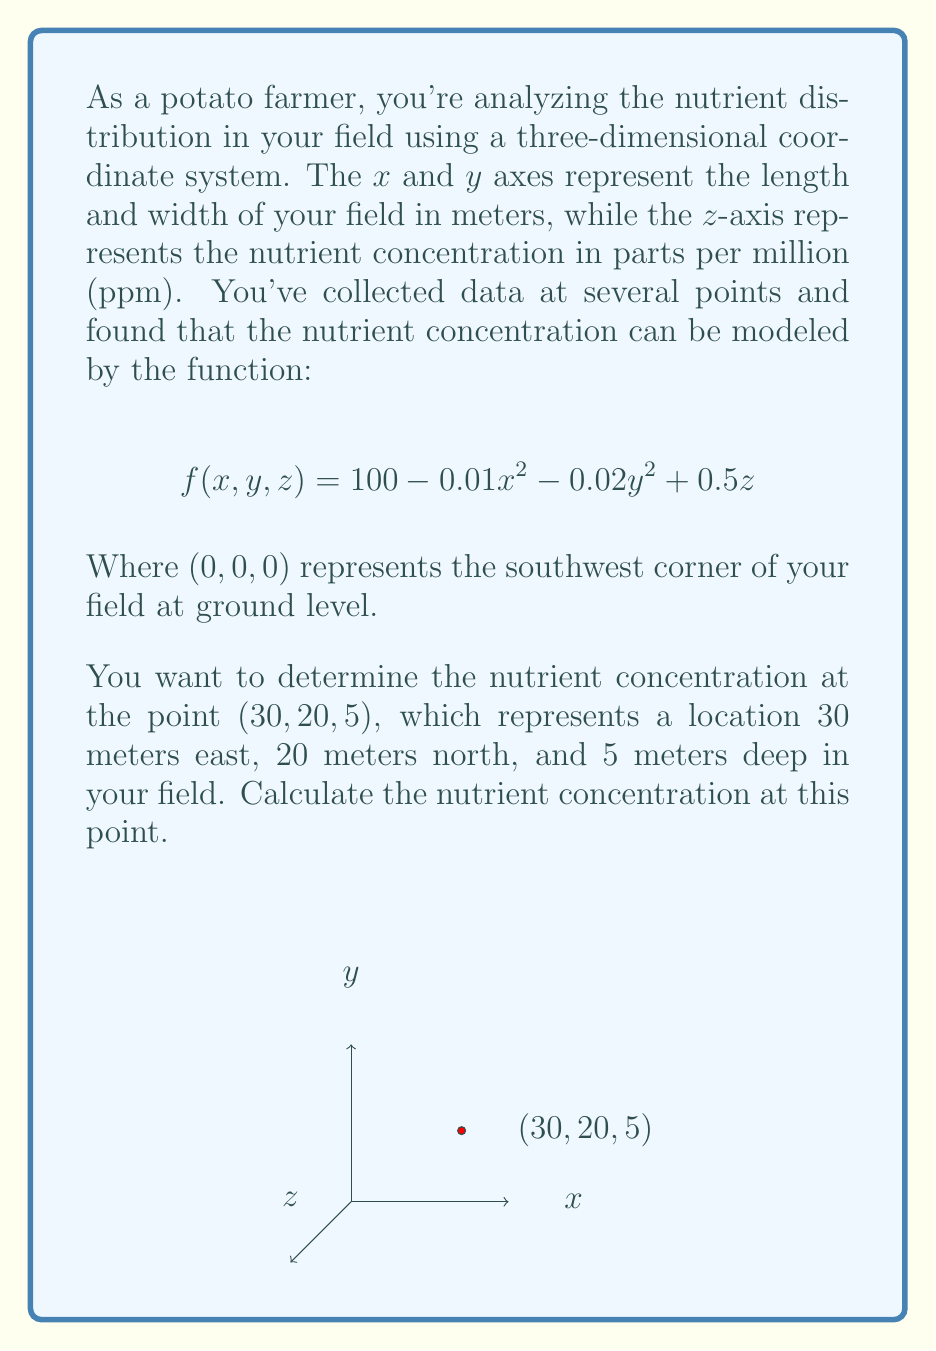Provide a solution to this math problem. Let's approach this step-by-step:

1) We're given the function for nutrient concentration:
   $$f(x,y,z) = 100 - 0.01x^2 - 0.02y^2 + 0.5z$$

2) We need to find the value of this function at the point $(30, 20, 5)$. So, we'll substitute these values into the equation:
   $x = 30$
   $y = 20$
   $z = 5$

3) Let's substitute these values into our function:
   $$f(30,20,5) = 100 - 0.01(30)^2 - 0.02(20)^2 + 0.5(5)$$

4) Now, let's calculate each term:
   - $0.01(30)^2 = 0.01 * 900 = 9$
   - $0.02(20)^2 = 0.02 * 400 = 8$
   - $0.5(5) = 2.5$

5) Substituting these back into our equation:
   $$f(30,20,5) = 100 - 9 - 8 + 2.5$$

6) Finally, let's perform the arithmetic:
   $$f(30,20,5) = 85.5$$

Therefore, the nutrient concentration at the point $(30, 20, 5)$ is 85.5 ppm.
Answer: 85.5 ppm 